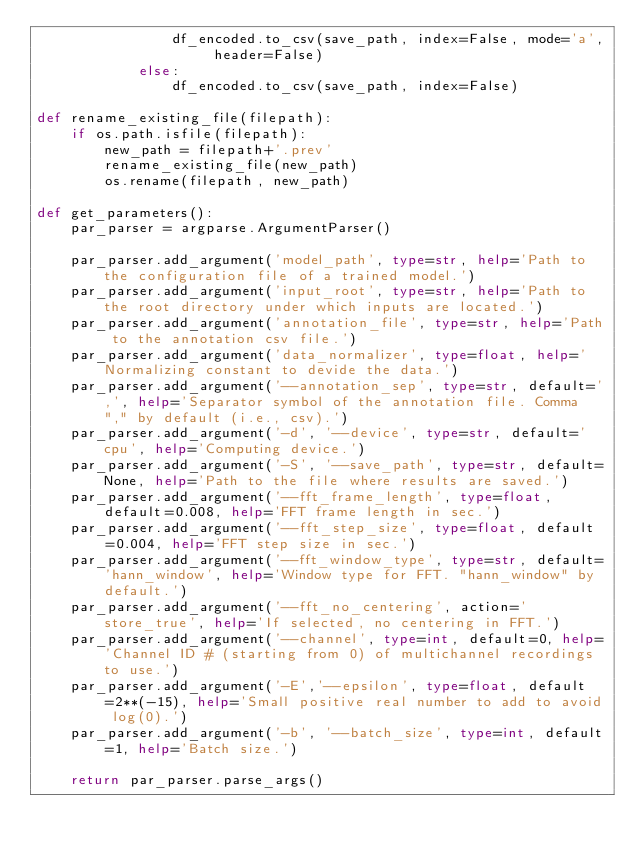<code> <loc_0><loc_0><loc_500><loc_500><_Python_>				df_encoded.to_csv(save_path, index=False, mode='a', header=False)
			else:
				df_encoded.to_csv(save_path, index=False)

def rename_existing_file(filepath):
	if os.path.isfile(filepath):
		new_path = filepath+'.prev'
		rename_existing_file(new_path)
		os.rename(filepath, new_path)

def get_parameters():
	par_parser = argparse.ArgumentParser()

	par_parser.add_argument('model_path', type=str, help='Path to the configuration file of a trained model.')
	par_parser.add_argument('input_root', type=str, help='Path to the root directory under which inputs are located.')
	par_parser.add_argument('annotation_file', type=str, help='Path to the annotation csv file.')
	par_parser.add_argument('data_normalizer', type=float, help='Normalizing constant to devide the data.')
	par_parser.add_argument('--annotation_sep', type=str, default=',', help='Separator symbol of the annotation file. Comma "," by default (i.e., csv).')
	par_parser.add_argument('-d', '--device', type=str, default='cpu', help='Computing device.')
	par_parser.add_argument('-S', '--save_path', type=str, default=None, help='Path to the file where results are saved.')
	par_parser.add_argument('--fft_frame_length', type=float, default=0.008, help='FFT frame length in sec.')
	par_parser.add_argument('--fft_step_size', type=float, default=0.004, help='FFT step size in sec.')
	par_parser.add_argument('--fft_window_type', type=str, default='hann_window', help='Window type for FFT. "hann_window" by default.')
	par_parser.add_argument('--fft_no_centering', action='store_true', help='If selected, no centering in FFT.')
	par_parser.add_argument('--channel', type=int, default=0, help='Channel ID # (starting from 0) of multichannel recordings to use.')
	par_parser.add_argument('-E','--epsilon', type=float, default=2**(-15), help='Small positive real number to add to avoid log(0).')
	par_parser.add_argument('-b', '--batch_size', type=int, default=1, help='Batch size.')

	return par_parser.parse_args()
</code> 